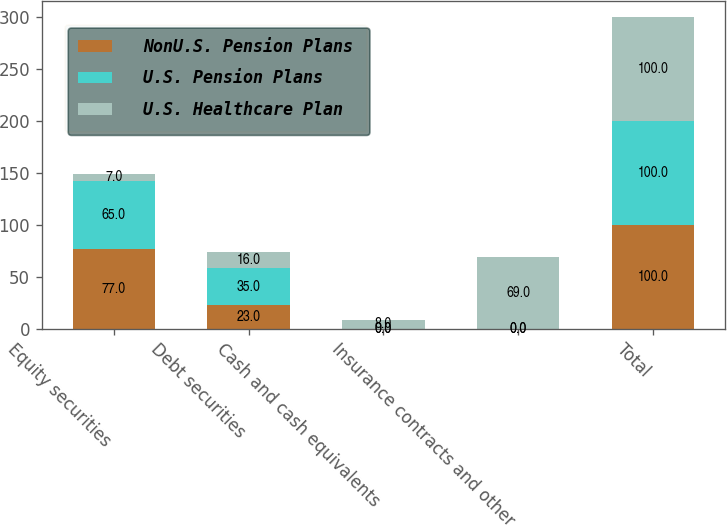<chart> <loc_0><loc_0><loc_500><loc_500><stacked_bar_chart><ecel><fcel>Equity securities<fcel>Debt securities<fcel>Cash and cash equivalents<fcel>Insurance contracts and other<fcel>Total<nl><fcel>NonU.S. Pension Plans<fcel>77<fcel>23<fcel>0<fcel>0<fcel>100<nl><fcel>U.S. Pension Plans<fcel>65<fcel>35<fcel>0<fcel>0<fcel>100<nl><fcel>U.S. Healthcare Plan<fcel>7<fcel>16<fcel>8<fcel>69<fcel>100<nl></chart> 